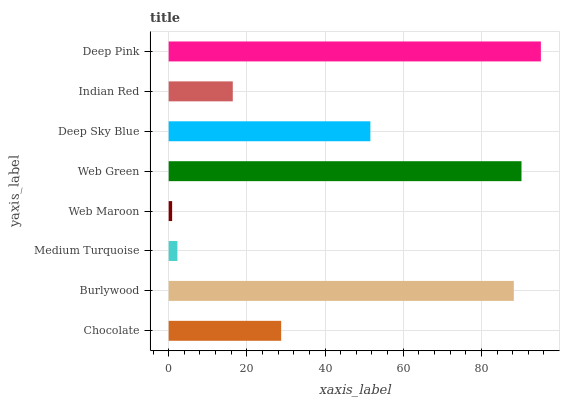Is Web Maroon the minimum?
Answer yes or no. Yes. Is Deep Pink the maximum?
Answer yes or no. Yes. Is Burlywood the minimum?
Answer yes or no. No. Is Burlywood the maximum?
Answer yes or no. No. Is Burlywood greater than Chocolate?
Answer yes or no. Yes. Is Chocolate less than Burlywood?
Answer yes or no. Yes. Is Chocolate greater than Burlywood?
Answer yes or no. No. Is Burlywood less than Chocolate?
Answer yes or no. No. Is Deep Sky Blue the high median?
Answer yes or no. Yes. Is Chocolate the low median?
Answer yes or no. Yes. Is Web Green the high median?
Answer yes or no. No. Is Web Green the low median?
Answer yes or no. No. 